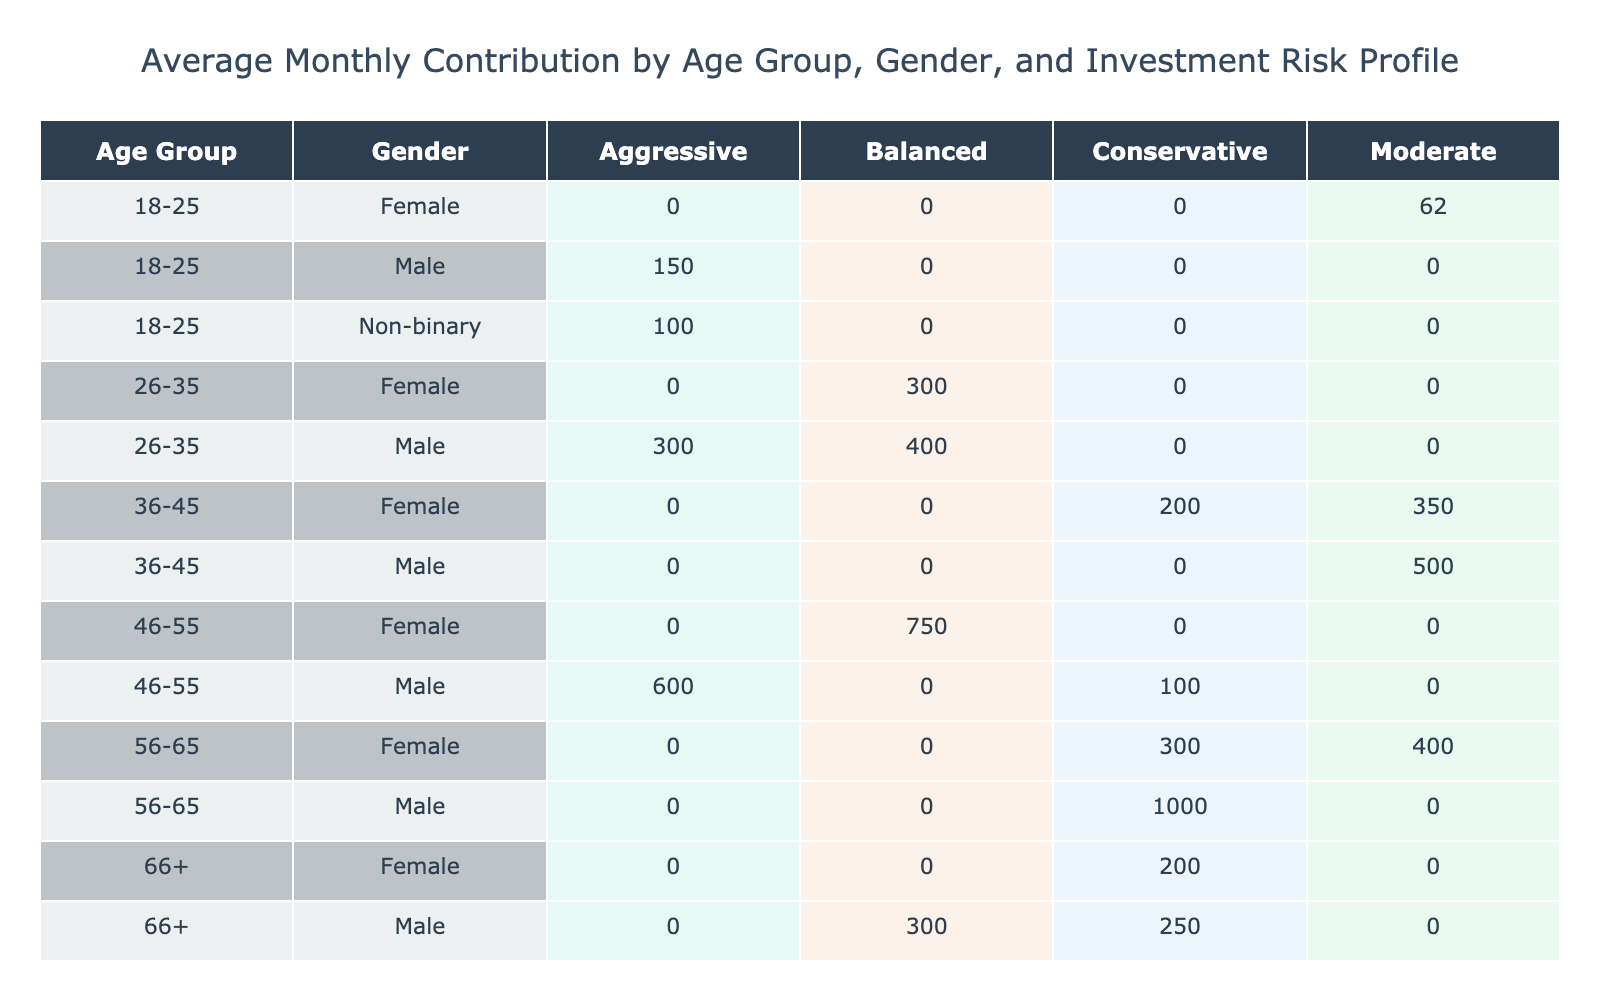What is the average monthly contribution for females in the age group 36-45 with a moderate risk profile? In the table, for females in the age group 36-45 under a moderate risk profile, there is one entry with a monthly contribution of £200. Since there's only one data point, the average is simply that value.
Answer: 200 Which age group contributes the most on average under an aggressive investment risk profile? Examining the table, we see the aggressive risk profile contributions: for 18-25, it's £150; for 26-35, it's £250; for 36-45, it's £500; for 46-55, it's £600. Among these, £600 is the highest contribution, which comes from the 46-55 age group.
Answer: 46-55 Is there any male contributor from the age group 66+ who has a balanced investment risk profile? Looking at the table for age group 66+, we have one male contributor listed with a balanced risk profile, contributing £300 under retirement status. Thus, the answer is yes.
Answer: Yes What is the total monthly contribution from all females aged 56-65? For females in the age group 56-65, the contributions captured in the table are £400 from one entry and £300 from another. Summing these gives £400 + £300 = £700, which is the total monthly contribution from this group.
Answer: 700 How many members contribute a monthly amount below £100 in the 18-25 age group? In the age group 18-25, the contributions listed are £150, £75, and £100. The only amount below £100 is £75, which corresponds to one female in Manchester. Therefore, there is one member contributing below £100 in this age group.
Answer: 1 Which age group has the highest average contribution across all genders? To find the age group with the highest average contribution, we calculate the averages by summing each group's contributions and dividing by the number of members: 18-25 (150+75+100=325/3=108.33), 26-35 (300+250+400+350=1300/4=325), 36-45 (500+200+350=1050/3=350), 46-55 (750+100+600=1450/3=483.33), 56-65 (1000+400+300=1700/3=566.67), and 66+ (200+300+250=750/3=250). The 56-65 age group has the highest average at £566.67.
Answer: 56-65 Are there any non-binary members in the 26-35 age group contributing above £300? In the table, the only non-binary member listed is aged 18-25 with a contribution of £100. Thus, there are no non-binary members in the 26-35 age group contributing above £300.
Answer: No What is the difference in average contributions between the age groups 26-35 and 36-45? For 26-35, the average contribution is (£300 + £250 + £400 + £350) / 4 = £325. For 36-45, the average contribution is (£500 + £200 + £350) / 3 = £350. The difference between the average contributions is £350 - £325 = £25.
Answer: 25 